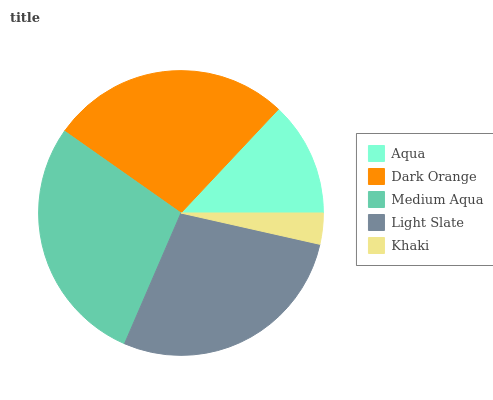Is Khaki the minimum?
Answer yes or no. Yes. Is Medium Aqua the maximum?
Answer yes or no. Yes. Is Dark Orange the minimum?
Answer yes or no. No. Is Dark Orange the maximum?
Answer yes or no. No. Is Dark Orange greater than Aqua?
Answer yes or no. Yes. Is Aqua less than Dark Orange?
Answer yes or no. Yes. Is Aqua greater than Dark Orange?
Answer yes or no. No. Is Dark Orange less than Aqua?
Answer yes or no. No. Is Dark Orange the high median?
Answer yes or no. Yes. Is Dark Orange the low median?
Answer yes or no. Yes. Is Aqua the high median?
Answer yes or no. No. Is Medium Aqua the low median?
Answer yes or no. No. 